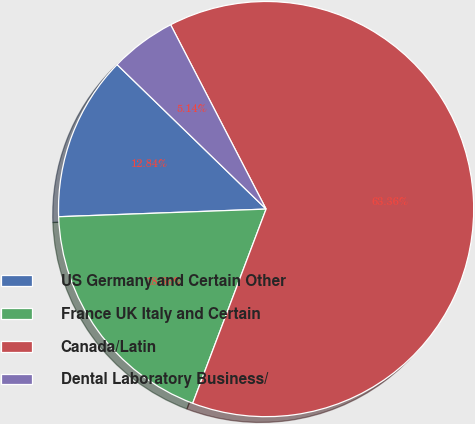<chart> <loc_0><loc_0><loc_500><loc_500><pie_chart><fcel>US Germany and Certain Other<fcel>France UK Italy and Certain<fcel>Canada/Latin<fcel>Dental Laboratory Business/<nl><fcel>12.84%<fcel>18.66%<fcel>63.35%<fcel>5.14%<nl></chart> 